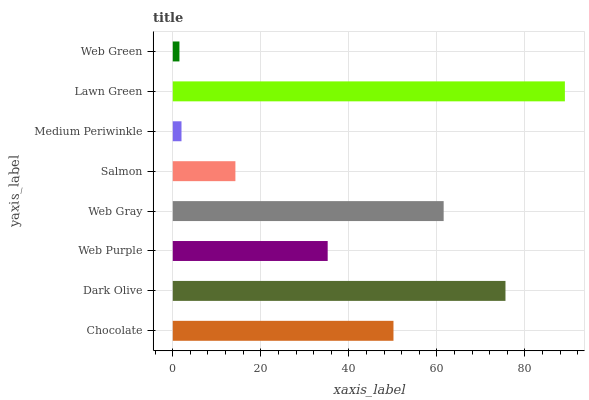Is Web Green the minimum?
Answer yes or no. Yes. Is Lawn Green the maximum?
Answer yes or no. Yes. Is Dark Olive the minimum?
Answer yes or no. No. Is Dark Olive the maximum?
Answer yes or no. No. Is Dark Olive greater than Chocolate?
Answer yes or no. Yes. Is Chocolate less than Dark Olive?
Answer yes or no. Yes. Is Chocolate greater than Dark Olive?
Answer yes or no. No. Is Dark Olive less than Chocolate?
Answer yes or no. No. Is Chocolate the high median?
Answer yes or no. Yes. Is Web Purple the low median?
Answer yes or no. Yes. Is Dark Olive the high median?
Answer yes or no. No. Is Chocolate the low median?
Answer yes or no. No. 